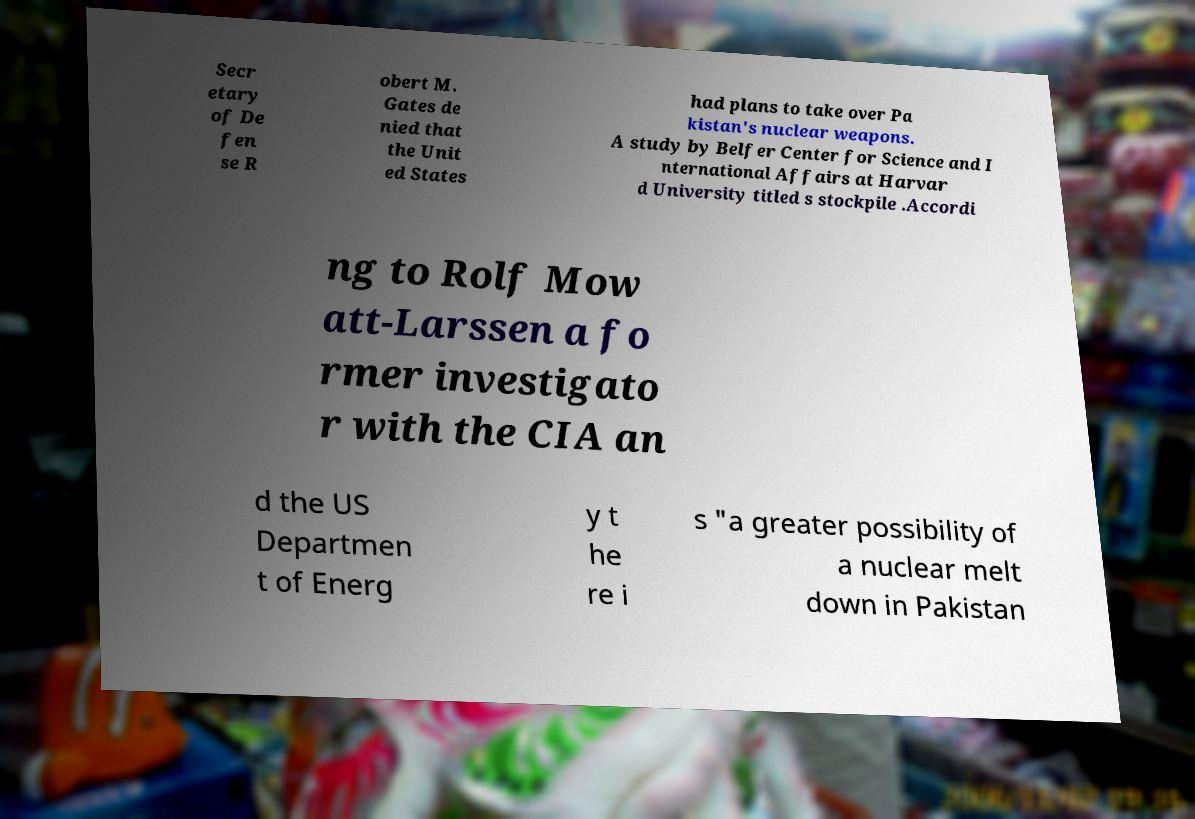Could you extract and type out the text from this image? Secr etary of De fen se R obert M. Gates de nied that the Unit ed States had plans to take over Pa kistan's nuclear weapons. A study by Belfer Center for Science and I nternational Affairs at Harvar d University titled s stockpile .Accordi ng to Rolf Mow att-Larssen a fo rmer investigato r with the CIA an d the US Departmen t of Energ y t he re i s "a greater possibility of a nuclear melt down in Pakistan 